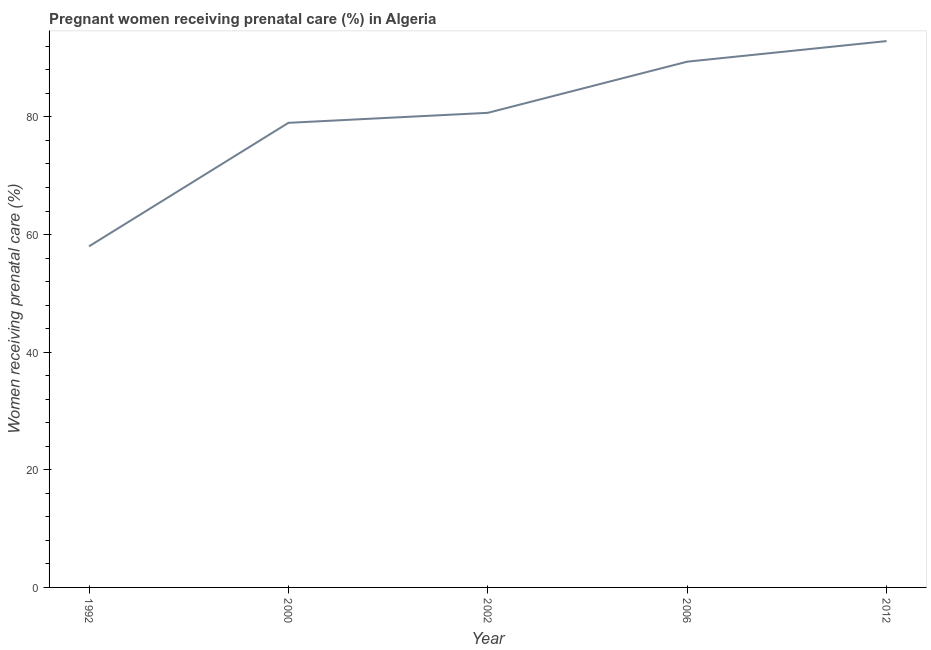What is the percentage of pregnant women receiving prenatal care in 2012?
Your answer should be compact. 92.9. Across all years, what is the maximum percentage of pregnant women receiving prenatal care?
Provide a succinct answer. 92.9. Across all years, what is the minimum percentage of pregnant women receiving prenatal care?
Your answer should be very brief. 58. What is the difference between the percentage of pregnant women receiving prenatal care in 2000 and 2002?
Your answer should be compact. -1.7. What is the median percentage of pregnant women receiving prenatal care?
Your answer should be very brief. 80.7. In how many years, is the percentage of pregnant women receiving prenatal care greater than 76 %?
Offer a very short reply. 4. Do a majority of the years between 2000 and 2002 (inclusive) have percentage of pregnant women receiving prenatal care greater than 8 %?
Provide a short and direct response. Yes. What is the ratio of the percentage of pregnant women receiving prenatal care in 2002 to that in 2012?
Your answer should be very brief. 0.87. Is the difference between the percentage of pregnant women receiving prenatal care in 2006 and 2012 greater than the difference between any two years?
Offer a terse response. No. What is the difference between the highest and the second highest percentage of pregnant women receiving prenatal care?
Give a very brief answer. 3.5. What is the difference between the highest and the lowest percentage of pregnant women receiving prenatal care?
Your answer should be compact. 34.9. How many lines are there?
Make the answer very short. 1. How many years are there in the graph?
Make the answer very short. 5. Are the values on the major ticks of Y-axis written in scientific E-notation?
Ensure brevity in your answer.  No. Does the graph contain grids?
Your response must be concise. No. What is the title of the graph?
Keep it short and to the point. Pregnant women receiving prenatal care (%) in Algeria. What is the label or title of the X-axis?
Your answer should be very brief. Year. What is the label or title of the Y-axis?
Your response must be concise. Women receiving prenatal care (%). What is the Women receiving prenatal care (%) of 2000?
Give a very brief answer. 79. What is the Women receiving prenatal care (%) in 2002?
Offer a very short reply. 80.7. What is the Women receiving prenatal care (%) in 2006?
Provide a succinct answer. 89.4. What is the Women receiving prenatal care (%) of 2012?
Your response must be concise. 92.9. What is the difference between the Women receiving prenatal care (%) in 1992 and 2002?
Your answer should be compact. -22.7. What is the difference between the Women receiving prenatal care (%) in 1992 and 2006?
Your response must be concise. -31.4. What is the difference between the Women receiving prenatal care (%) in 1992 and 2012?
Offer a very short reply. -34.9. What is the difference between the Women receiving prenatal care (%) in 2000 and 2002?
Keep it short and to the point. -1.7. What is the difference between the Women receiving prenatal care (%) in 2000 and 2006?
Ensure brevity in your answer.  -10.4. What is the difference between the Women receiving prenatal care (%) in 2006 and 2012?
Offer a very short reply. -3.5. What is the ratio of the Women receiving prenatal care (%) in 1992 to that in 2000?
Keep it short and to the point. 0.73. What is the ratio of the Women receiving prenatal care (%) in 1992 to that in 2002?
Make the answer very short. 0.72. What is the ratio of the Women receiving prenatal care (%) in 1992 to that in 2006?
Offer a very short reply. 0.65. What is the ratio of the Women receiving prenatal care (%) in 1992 to that in 2012?
Offer a very short reply. 0.62. What is the ratio of the Women receiving prenatal care (%) in 2000 to that in 2006?
Give a very brief answer. 0.88. What is the ratio of the Women receiving prenatal care (%) in 2002 to that in 2006?
Provide a short and direct response. 0.9. What is the ratio of the Women receiving prenatal care (%) in 2002 to that in 2012?
Make the answer very short. 0.87. What is the ratio of the Women receiving prenatal care (%) in 2006 to that in 2012?
Provide a succinct answer. 0.96. 